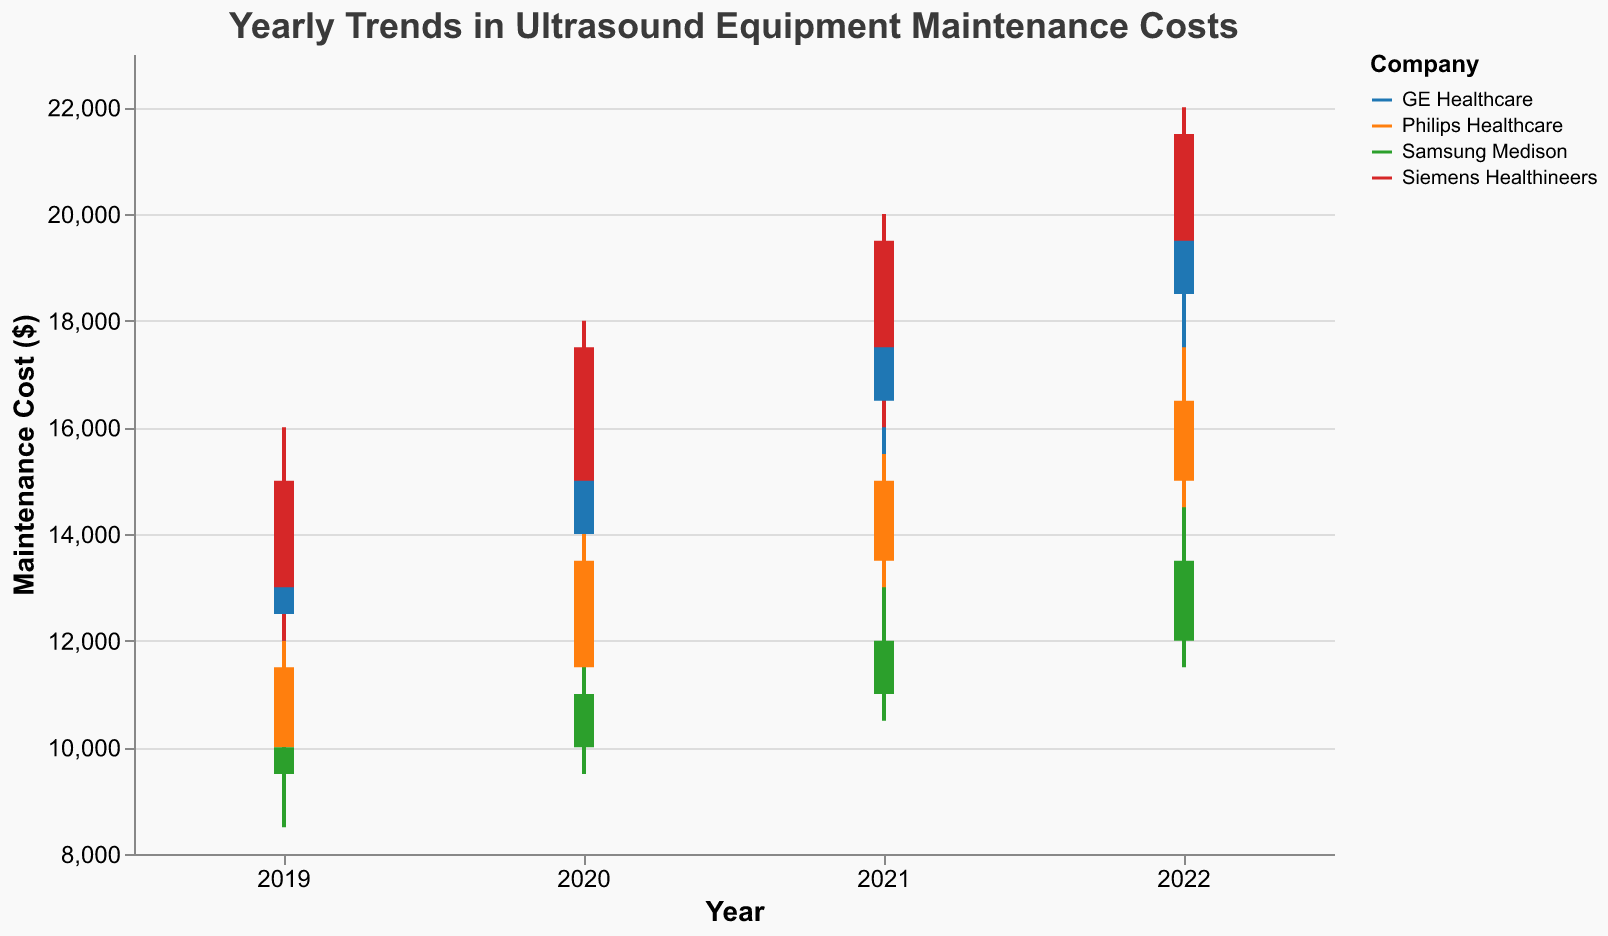How much were the maintenance costs for GE Healthcare in 2020? Looking at the candlestick figure for GE Healthcare in 2020, we see that the close price is around $16,500.
Answer: $16,500 Which company had the highest maintenance cost in 2022? Observing the high values for 2022, Siemens Healthineers shows the highest value at $22,000.
Answer: Siemens Healthineers Did Philips Healthcare have an increase or decrease in maintenance costs from 2020 to 2021? Comparing the close prices of Philips Healthcare, it was $13,500 in 2020 and $15,000 in 2021, indicating an increase.
Answer: Increase What was the total range of maintenance costs for Samsung Medison in 2019? The range can be calculated by subtracting the low value from the high value. For Samsung Medison in 2019, it is $10,500 - $8,500 = $2,000.
Answer: $2,000 What is the largest increase in closing maintenance costs from one year to the next for Siemens Healthineers? Evaluating the closing values from year to year: 
2019: $15,000 
2020: $17,500 
2021: $19,500 
2022: $21,500 
The largest year-to-year increase is from 2019 to 2020, which is $17,500 - $15,000 = $2,500.
Answer: $2,500 Which year had the lowest maintenance cost for Samsung Medison and what was the value? Checking the candlesticks for Samsung Medison, the lowest close was in 2019 at $10,000.
Answer: 2019, $10,000 What is the median maintenance cost for Philips Healthcare over the 4-year period? Sorting the close prices for Philips Healthcare from lowest to highest ($11,500, $13,500, $15,000, $16,500), the median is the average of $13,500 and $15,000, which is $(13,500 + 15,000) / 2 = $14,250.
Answer: $14,250 Compare the opening and closing maintenance costs of GE Healthcare in 2021. Were they the same? Looking at the open ($16,500) and close ($18,500) prices for GE Healthcare in 2021, they are not the same.
Answer: No How did the maintenance costs of GE Healthcare change from 2019 to 2022? Observing the opening values over these years: 
2019: $12,500 
2020: $14,000 
2021: $16,500 
2022: $18,500 
The costs increased each year.
Answer: Increased 